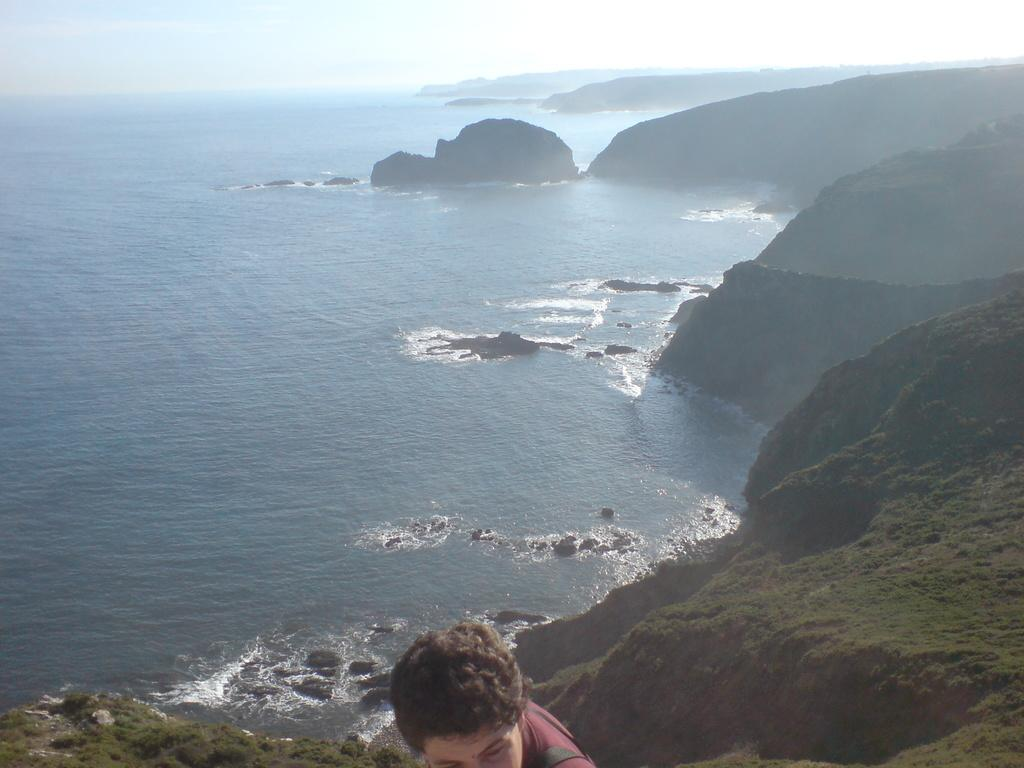Who or what is present in the image? There is a person in the image. What is the person wearing? The person is wearing a maroon color dress. Where is the person located? The person is on a rock. What can be seen near the person? There is water visible near the person. What is visible in the background of the image? The sky is visible in the background of the image. What type of verse can be heard being recited by the person in the image? There is no indication in the image that the person is reciting a verse, so it cannot be determined from the picture. 